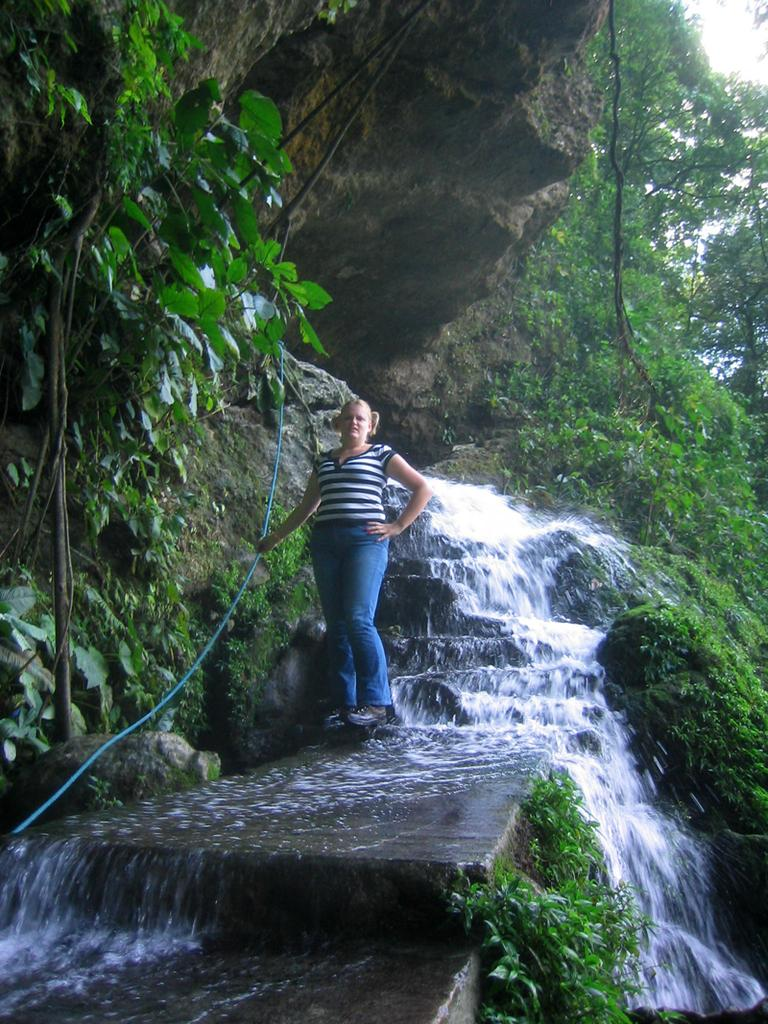What is the main subject in the image? There is a woman standing in the image. What natural feature can be seen in the background? There is a waterfall in the image. What type of vegetation is visible on the hill? There are trees on a hill in the image. What is the condition of the sky in the image? The sun is shining at the top of the image. What type of plastic is covering the grass in the image? There is no plastic covering any grass in the image, as there is no grass present. 